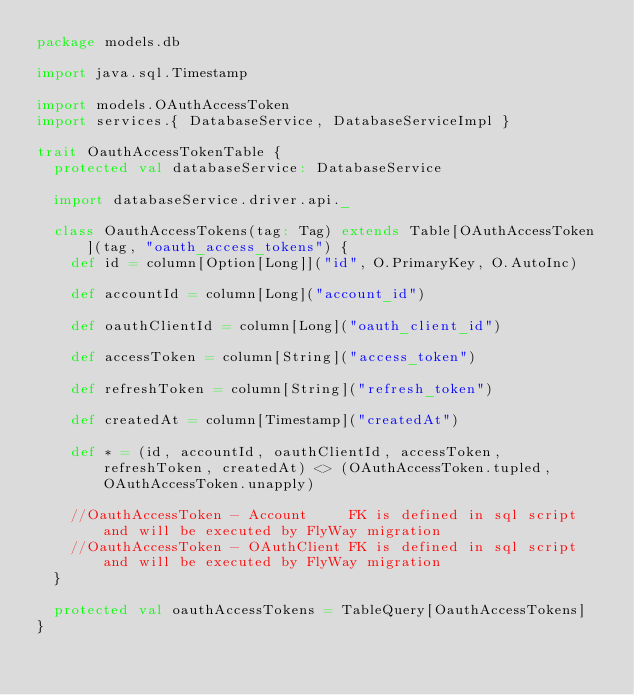<code> <loc_0><loc_0><loc_500><loc_500><_Scala_>package models.db

import java.sql.Timestamp

import models.OAuthAccessToken
import services.{ DatabaseService, DatabaseServiceImpl }

trait OauthAccessTokenTable {
  protected val databaseService: DatabaseService

  import databaseService.driver.api._

  class OauthAccessTokens(tag: Tag) extends Table[OAuthAccessToken](tag, "oauth_access_tokens") {
    def id = column[Option[Long]]("id", O.PrimaryKey, O.AutoInc)

    def accountId = column[Long]("account_id")

    def oauthClientId = column[Long]("oauth_client_id")

    def accessToken = column[String]("access_token")

    def refreshToken = column[String]("refresh_token")

    def createdAt = column[Timestamp]("createdAt")

    def * = (id, accountId, oauthClientId, accessToken, refreshToken, createdAt) <> (OAuthAccessToken.tupled, OAuthAccessToken.unapply)

    //OauthAccessToken - Account     FK is defined in sql script and will be executed by FlyWay migration
    //OauthAccessToken - OAuthClient FK is defined in sql script and will be executed by FlyWay migration
  }

  protected val oauthAccessTokens = TableQuery[OauthAccessTokens]
}
</code> 